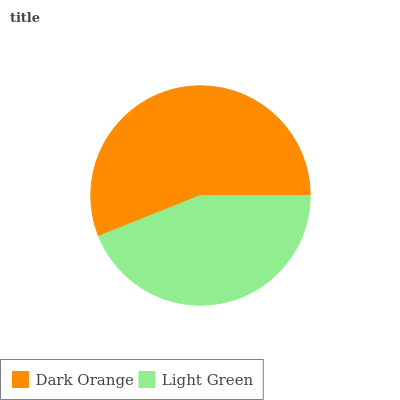Is Light Green the minimum?
Answer yes or no. Yes. Is Dark Orange the maximum?
Answer yes or no. Yes. Is Light Green the maximum?
Answer yes or no. No. Is Dark Orange greater than Light Green?
Answer yes or no. Yes. Is Light Green less than Dark Orange?
Answer yes or no. Yes. Is Light Green greater than Dark Orange?
Answer yes or no. No. Is Dark Orange less than Light Green?
Answer yes or no. No. Is Dark Orange the high median?
Answer yes or no. Yes. Is Light Green the low median?
Answer yes or no. Yes. Is Light Green the high median?
Answer yes or no. No. Is Dark Orange the low median?
Answer yes or no. No. 